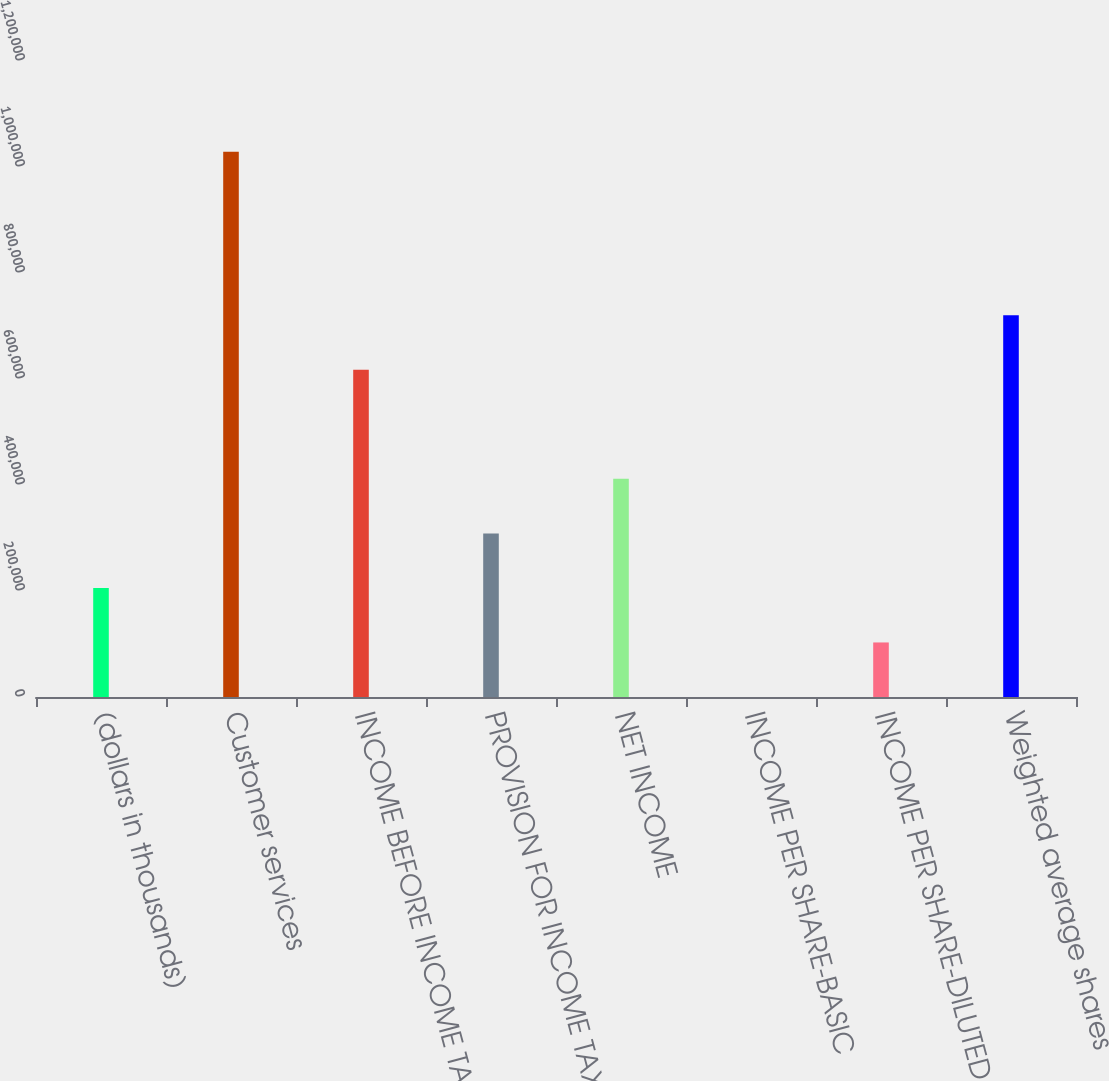<chart> <loc_0><loc_0><loc_500><loc_500><bar_chart><fcel>(dollars in thousands)<fcel>Customer services<fcel>INCOME BEFORE INCOME TAXES<fcel>PROVISION FOR INCOME TAXES<fcel>NET INCOME<fcel>INCOME PER SHARE-BASIC<fcel>INCOME PER SHARE-DILUTED<fcel>Weighted average shares<nl><fcel>205801<fcel>1.029e+06<fcel>617403<fcel>308702<fcel>411602<fcel>0.62<fcel>102901<fcel>720303<nl></chart> 